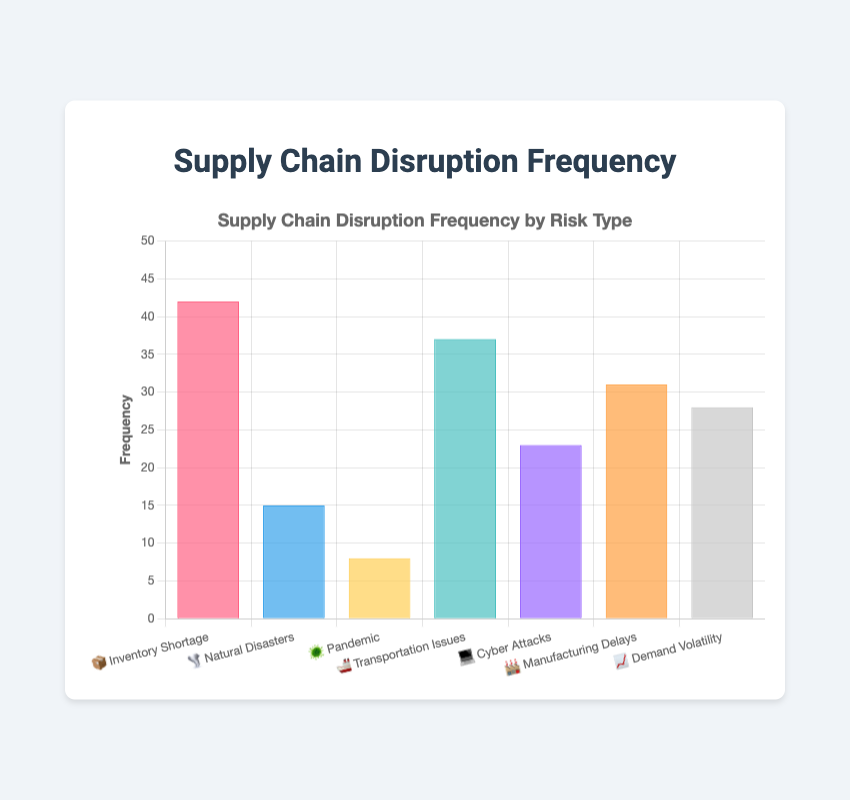Which risk type has the highest disruption frequency? Look at the bar with the highest value. The "Inventory Shortage 📦" bar reaches the highest point on the frequency axis.
Answer: Inventory Shortage 📦 What is the frequency of Cyber Attacks? Find the "Cyber Attacks 💻" bar and read its height on the frequency axis. It reaches up to 23.
Answer: 23 How many risk types have a frequency greater than 30? Count the risk types whose bars exceed the value of 30 on the frequency axis: "Inventory Shortage 📦" (42), "Transportation Issues 🚢" (37), "Manufacturing Delays 🏭" (31).
Answer: 3 What is the combined frequency of Natural Disasters and Pandemics? Add the frequencies of "Natural Disasters 🌪️" (15) and "Pandemic 🦠" (8). The sum is 15 + 8 = 23.
Answer: 23 Which risk type has the second lowest disruption frequency? Rank the frequencies in ascending order and identify the second one from the bottom. "Pandemic 🦠" has the lowest frequency (8). "Natural Disasters 🌪️" is the next (15).
Answer: Natural Disasters 🌪️ Compare the frequencies of Demand Volatility and Manufacturing Delays. Which is higher? Compare "Demand Volatility 📈" (28) and "Manufacturing Delays 🏭" (31). "Manufacturing Delays 🏭" has a higher frequency.
Answer: Manufacturing Delays 🏭 What is the average frequency of recorded disruption types? Sum all the frequencies and divide by the number of risk types. (42 + 15 + 8 + 37 + 23 + 31 + 28) / 7 = 184 / 7 ≈ 26.29.
Answer: 26.29 What's the frequency difference between the highest and lowest disruption types? Subtract the smallest frequency (Pandemic 🦠, 8) from the largest frequency (Inventory Shortage 📦, 42). The difference is 42 - 8 = 34.
Answer: 34 List the risk types with disruption frequencies below 20. Identify the risk types whose bars fall below the 20 mark on the frequency axis: "Natural Disasters 🌪️" (15) and "Pandemic 🦠" (8).
Answer: Natural Disasters 🌪️, Pandemic 🦠 What is the total disruption frequency for all risk types combined? Sum up all the disruption frequencies: 42 (Inventory Shortage) + 15 (Natural Disasters) + 8 (Pandemic) + 37 (Transportation Issues) + 23 (Cyber Attacks) + 31 (Manufacturing Delays) + 28 (Demand Volatility) = 184.
Answer: 184 